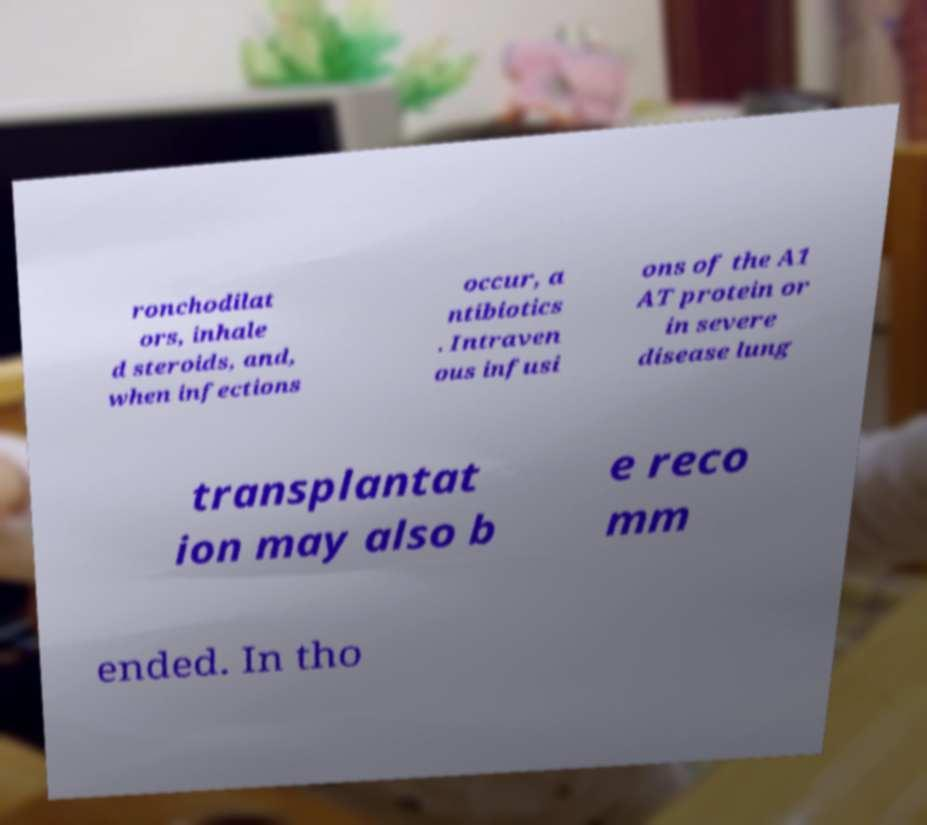For documentation purposes, I need the text within this image transcribed. Could you provide that? ronchodilat ors, inhale d steroids, and, when infections occur, a ntibiotics . Intraven ous infusi ons of the A1 AT protein or in severe disease lung transplantat ion may also b e reco mm ended. In tho 